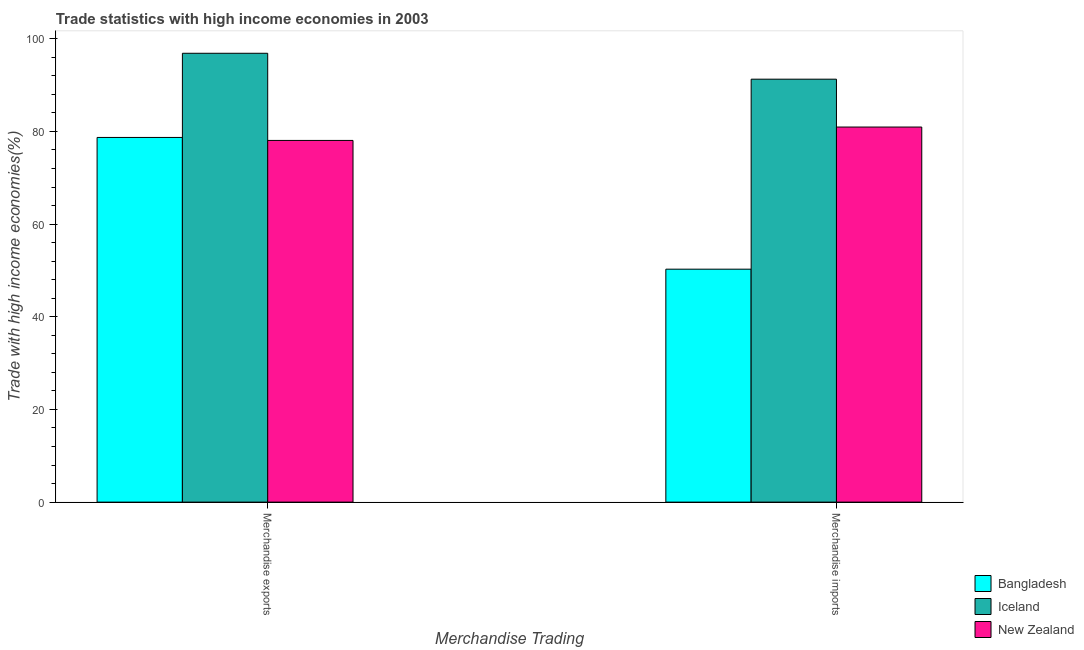How many bars are there on the 1st tick from the right?
Provide a succinct answer. 3. What is the label of the 1st group of bars from the left?
Offer a terse response. Merchandise exports. What is the merchandise exports in Bangladesh?
Make the answer very short. 78.69. Across all countries, what is the maximum merchandise imports?
Offer a very short reply. 91.27. Across all countries, what is the minimum merchandise exports?
Offer a terse response. 78.05. In which country was the merchandise imports minimum?
Your answer should be compact. Bangladesh. What is the total merchandise imports in the graph?
Offer a terse response. 222.48. What is the difference between the merchandise imports in Iceland and that in Bangladesh?
Give a very brief answer. 41. What is the difference between the merchandise exports in New Zealand and the merchandise imports in Iceland?
Offer a very short reply. -13.22. What is the average merchandise imports per country?
Make the answer very short. 74.16. What is the difference between the merchandise exports and merchandise imports in New Zealand?
Offer a terse response. -2.89. In how many countries, is the merchandise exports greater than 16 %?
Make the answer very short. 3. What is the ratio of the merchandise exports in Iceland to that in Bangladesh?
Offer a very short reply. 1.23. What does the 2nd bar from the left in Merchandise exports represents?
Your response must be concise. Iceland. What does the 1st bar from the right in Merchandise exports represents?
Your response must be concise. New Zealand. What is the difference between two consecutive major ticks on the Y-axis?
Your response must be concise. 20. Where does the legend appear in the graph?
Your response must be concise. Bottom right. What is the title of the graph?
Offer a terse response. Trade statistics with high income economies in 2003. What is the label or title of the X-axis?
Your answer should be very brief. Merchandise Trading. What is the label or title of the Y-axis?
Make the answer very short. Trade with high income economies(%). What is the Trade with high income economies(%) of Bangladesh in Merchandise exports?
Your response must be concise. 78.69. What is the Trade with high income economies(%) in Iceland in Merchandise exports?
Provide a short and direct response. 96.86. What is the Trade with high income economies(%) of New Zealand in Merchandise exports?
Make the answer very short. 78.05. What is the Trade with high income economies(%) in Bangladesh in Merchandise imports?
Give a very brief answer. 50.27. What is the Trade with high income economies(%) in Iceland in Merchandise imports?
Your answer should be compact. 91.27. What is the Trade with high income economies(%) of New Zealand in Merchandise imports?
Provide a short and direct response. 80.94. Across all Merchandise Trading, what is the maximum Trade with high income economies(%) in Bangladesh?
Make the answer very short. 78.69. Across all Merchandise Trading, what is the maximum Trade with high income economies(%) in Iceland?
Offer a terse response. 96.86. Across all Merchandise Trading, what is the maximum Trade with high income economies(%) in New Zealand?
Make the answer very short. 80.94. Across all Merchandise Trading, what is the minimum Trade with high income economies(%) in Bangladesh?
Give a very brief answer. 50.27. Across all Merchandise Trading, what is the minimum Trade with high income economies(%) of Iceland?
Your response must be concise. 91.27. Across all Merchandise Trading, what is the minimum Trade with high income economies(%) in New Zealand?
Provide a succinct answer. 78.05. What is the total Trade with high income economies(%) of Bangladesh in the graph?
Provide a succinct answer. 128.96. What is the total Trade with high income economies(%) of Iceland in the graph?
Offer a terse response. 188.13. What is the total Trade with high income economies(%) of New Zealand in the graph?
Your response must be concise. 158.99. What is the difference between the Trade with high income economies(%) in Bangladesh in Merchandise exports and that in Merchandise imports?
Your answer should be very brief. 28.43. What is the difference between the Trade with high income economies(%) in Iceland in Merchandise exports and that in Merchandise imports?
Provide a succinct answer. 5.59. What is the difference between the Trade with high income economies(%) in New Zealand in Merchandise exports and that in Merchandise imports?
Make the answer very short. -2.89. What is the difference between the Trade with high income economies(%) of Bangladesh in Merchandise exports and the Trade with high income economies(%) of Iceland in Merchandise imports?
Provide a succinct answer. -12.58. What is the difference between the Trade with high income economies(%) in Bangladesh in Merchandise exports and the Trade with high income economies(%) in New Zealand in Merchandise imports?
Give a very brief answer. -2.25. What is the difference between the Trade with high income economies(%) in Iceland in Merchandise exports and the Trade with high income economies(%) in New Zealand in Merchandise imports?
Your response must be concise. 15.92. What is the average Trade with high income economies(%) in Bangladesh per Merchandise Trading?
Your answer should be compact. 64.48. What is the average Trade with high income economies(%) of Iceland per Merchandise Trading?
Offer a terse response. 94.07. What is the average Trade with high income economies(%) in New Zealand per Merchandise Trading?
Make the answer very short. 79.5. What is the difference between the Trade with high income economies(%) in Bangladesh and Trade with high income economies(%) in Iceland in Merchandise exports?
Provide a short and direct response. -18.17. What is the difference between the Trade with high income economies(%) of Bangladesh and Trade with high income economies(%) of New Zealand in Merchandise exports?
Give a very brief answer. 0.64. What is the difference between the Trade with high income economies(%) in Iceland and Trade with high income economies(%) in New Zealand in Merchandise exports?
Your response must be concise. 18.81. What is the difference between the Trade with high income economies(%) of Bangladesh and Trade with high income economies(%) of Iceland in Merchandise imports?
Offer a very short reply. -41. What is the difference between the Trade with high income economies(%) of Bangladesh and Trade with high income economies(%) of New Zealand in Merchandise imports?
Your response must be concise. -30.67. What is the difference between the Trade with high income economies(%) in Iceland and Trade with high income economies(%) in New Zealand in Merchandise imports?
Offer a very short reply. 10.33. What is the ratio of the Trade with high income economies(%) of Bangladesh in Merchandise exports to that in Merchandise imports?
Offer a terse response. 1.57. What is the ratio of the Trade with high income economies(%) in Iceland in Merchandise exports to that in Merchandise imports?
Make the answer very short. 1.06. What is the ratio of the Trade with high income economies(%) in New Zealand in Merchandise exports to that in Merchandise imports?
Offer a terse response. 0.96. What is the difference between the highest and the second highest Trade with high income economies(%) of Bangladesh?
Offer a very short reply. 28.43. What is the difference between the highest and the second highest Trade with high income economies(%) of Iceland?
Give a very brief answer. 5.59. What is the difference between the highest and the second highest Trade with high income economies(%) in New Zealand?
Give a very brief answer. 2.89. What is the difference between the highest and the lowest Trade with high income economies(%) in Bangladesh?
Your answer should be very brief. 28.43. What is the difference between the highest and the lowest Trade with high income economies(%) of Iceland?
Your response must be concise. 5.59. What is the difference between the highest and the lowest Trade with high income economies(%) in New Zealand?
Offer a very short reply. 2.89. 